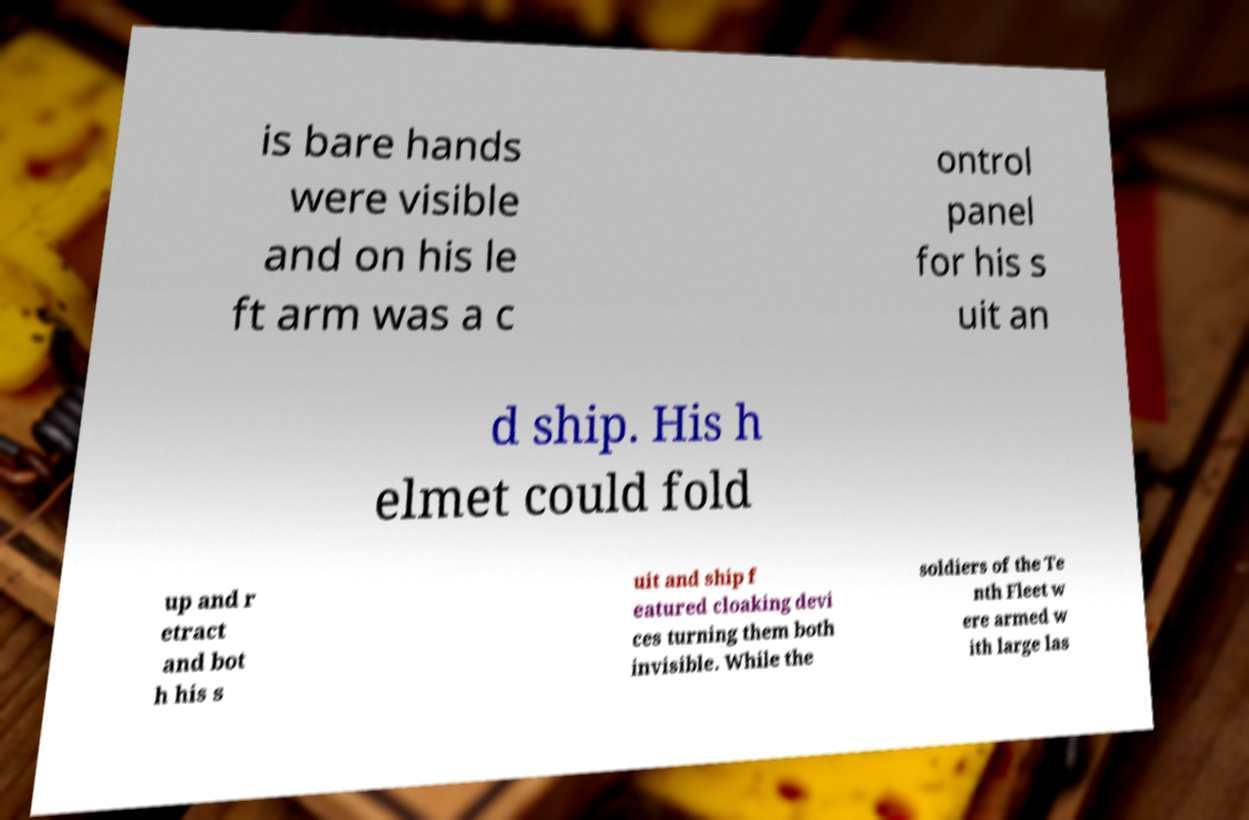Please read and relay the text visible in this image. What does it say? is bare hands were visible and on his le ft arm was a c ontrol panel for his s uit an d ship. His h elmet could fold up and r etract and bot h his s uit and ship f eatured cloaking devi ces turning them both invisible. While the soldiers of the Te nth Fleet w ere armed w ith large las 